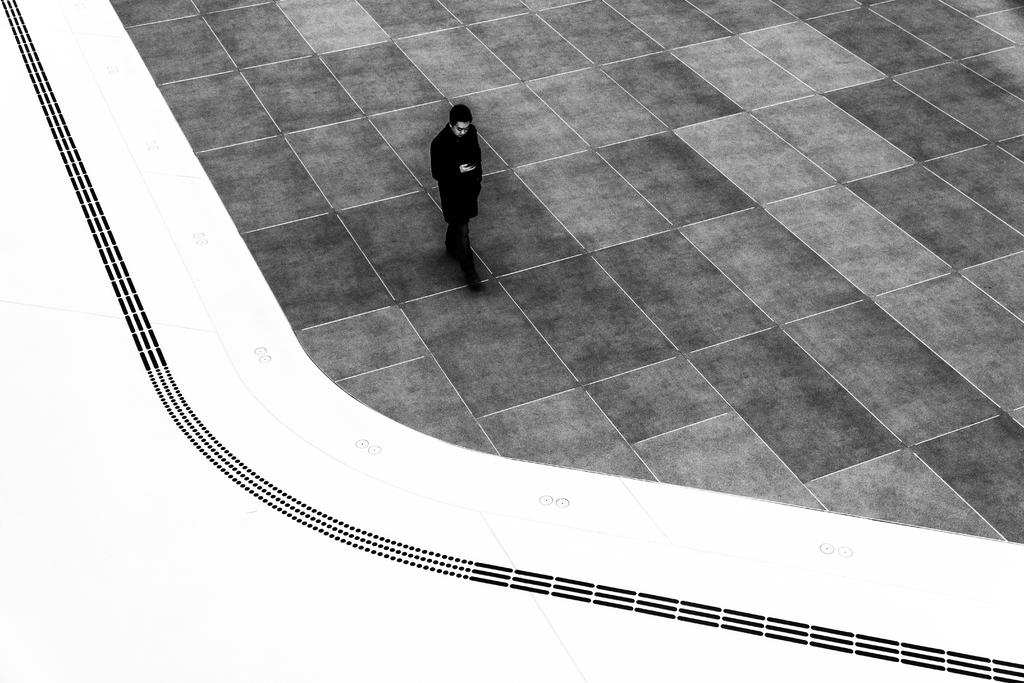What is present in the image? There is a person in the image. What is the person doing in the image? The person is walking in the image. On what surface is the person walking? The person is walking on a floor. What type of system is being developed by the person in the image? There is no indication in the image that the person is developing any system. 